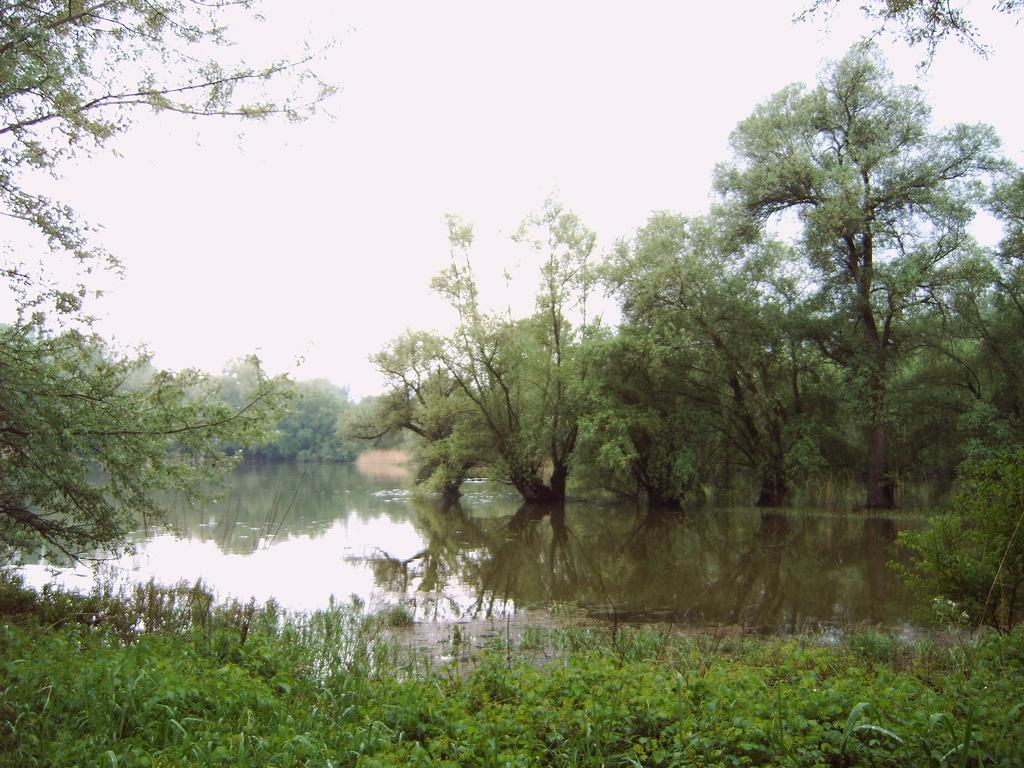What can be seen in the background of the image? The sky is visible in the background of the image. What type of vegetation is present in the image? There are trees and plants in the image. What natural element is visible in the image? There is water visible in the image. Is there any reflection on the water in the image? Yes, there is a reflection on the water in the image. What type of prose is being recited by the trees in the image? There is no indication in the image that the trees are reciting any prose. Is there any flesh visible in the image? There is no flesh visible in the image; it features natural elements such as trees, plants, water, and the sky. 